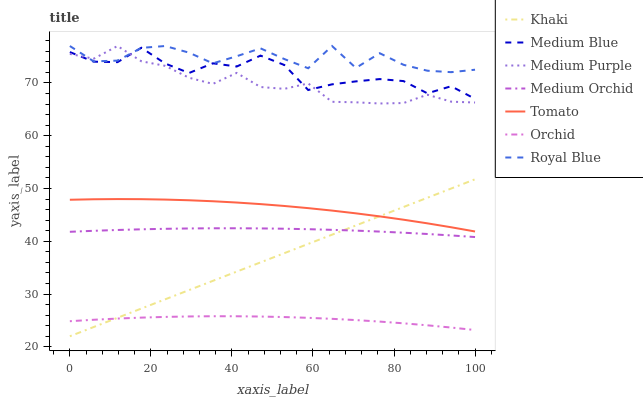Does Orchid have the minimum area under the curve?
Answer yes or no. Yes. Does Royal Blue have the maximum area under the curve?
Answer yes or no. Yes. Does Khaki have the minimum area under the curve?
Answer yes or no. No. Does Khaki have the maximum area under the curve?
Answer yes or no. No. Is Khaki the smoothest?
Answer yes or no. Yes. Is Royal Blue the roughest?
Answer yes or no. Yes. Is Medium Orchid the smoothest?
Answer yes or no. No. Is Medium Orchid the roughest?
Answer yes or no. No. Does Khaki have the lowest value?
Answer yes or no. Yes. Does Medium Orchid have the lowest value?
Answer yes or no. No. Does Royal Blue have the highest value?
Answer yes or no. Yes. Does Khaki have the highest value?
Answer yes or no. No. Is Orchid less than Medium Blue?
Answer yes or no. Yes. Is Medium Blue greater than Orchid?
Answer yes or no. Yes. Does Khaki intersect Tomato?
Answer yes or no. Yes. Is Khaki less than Tomato?
Answer yes or no. No. Is Khaki greater than Tomato?
Answer yes or no. No. Does Orchid intersect Medium Blue?
Answer yes or no. No. 